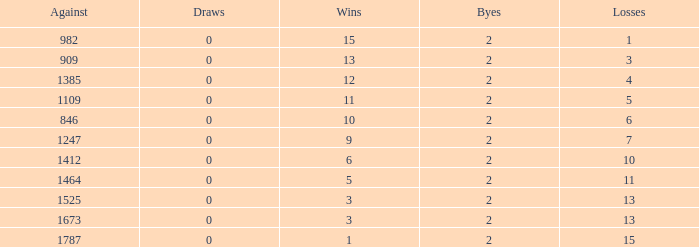What is the average number of Byes when there were less than 0 losses and were against 1247? None. 